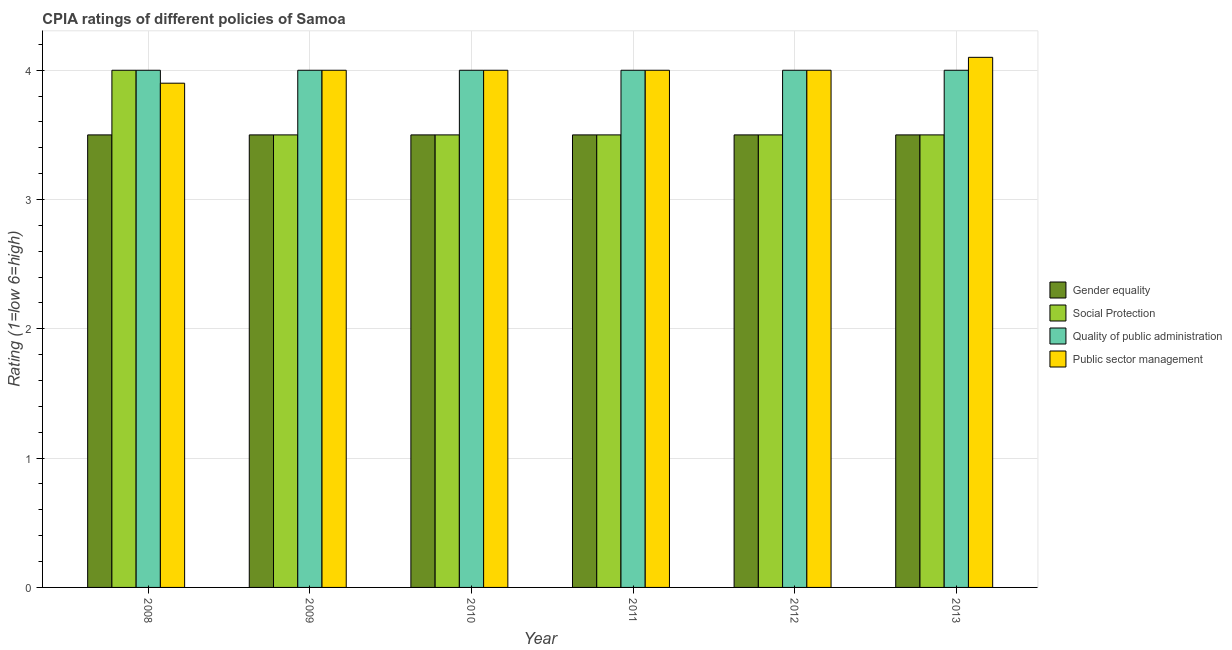How many bars are there on the 4th tick from the left?
Provide a short and direct response. 4. How many bars are there on the 6th tick from the right?
Your answer should be compact. 4. What is the label of the 1st group of bars from the left?
Give a very brief answer. 2008. What is the cpia rating of social protection in 2012?
Provide a short and direct response. 3.5. In which year was the cpia rating of quality of public administration maximum?
Make the answer very short. 2008. In which year was the cpia rating of gender equality minimum?
Give a very brief answer. 2008. What is the total cpia rating of social protection in the graph?
Provide a succinct answer. 21.5. What is the difference between the cpia rating of public sector management in 2010 and that in 2013?
Give a very brief answer. -0.1. What is the difference between the cpia rating of social protection in 2008 and the cpia rating of gender equality in 2011?
Your answer should be compact. 0.5. What is the average cpia rating of quality of public administration per year?
Provide a succinct answer. 4. Is the cpia rating of quality of public administration in 2011 less than that in 2012?
Your answer should be compact. No. Is the difference between the cpia rating of social protection in 2009 and 2012 greater than the difference between the cpia rating of quality of public administration in 2009 and 2012?
Make the answer very short. No. What is the difference between the highest and the second highest cpia rating of social protection?
Your answer should be compact. 0.5. What is the difference between the highest and the lowest cpia rating of social protection?
Keep it short and to the point. 0.5. Is the sum of the cpia rating of gender equality in 2008 and 2012 greater than the maximum cpia rating of public sector management across all years?
Make the answer very short. Yes. What does the 4th bar from the left in 2011 represents?
Offer a very short reply. Public sector management. What does the 2nd bar from the right in 2008 represents?
Give a very brief answer. Quality of public administration. How many bars are there?
Your answer should be compact. 24. Are all the bars in the graph horizontal?
Give a very brief answer. No. How many years are there in the graph?
Offer a terse response. 6. What is the difference between two consecutive major ticks on the Y-axis?
Your answer should be very brief. 1. Are the values on the major ticks of Y-axis written in scientific E-notation?
Your answer should be very brief. No. Does the graph contain any zero values?
Give a very brief answer. No. Does the graph contain grids?
Your answer should be compact. Yes. Where does the legend appear in the graph?
Your answer should be compact. Center right. How are the legend labels stacked?
Your answer should be compact. Vertical. What is the title of the graph?
Offer a terse response. CPIA ratings of different policies of Samoa. What is the Rating (1=low 6=high) of Quality of public administration in 2008?
Offer a very short reply. 4. What is the Rating (1=low 6=high) in Gender equality in 2009?
Ensure brevity in your answer.  3.5. What is the Rating (1=low 6=high) of Social Protection in 2009?
Your response must be concise. 3.5. What is the Rating (1=low 6=high) in Quality of public administration in 2009?
Ensure brevity in your answer.  4. What is the Rating (1=low 6=high) in Gender equality in 2010?
Offer a terse response. 3.5. What is the Rating (1=low 6=high) in Social Protection in 2010?
Provide a short and direct response. 3.5. What is the Rating (1=low 6=high) in Quality of public administration in 2010?
Your answer should be compact. 4. What is the Rating (1=low 6=high) in Public sector management in 2010?
Provide a succinct answer. 4. What is the Rating (1=low 6=high) of Public sector management in 2011?
Give a very brief answer. 4. What is the Rating (1=low 6=high) in Social Protection in 2012?
Give a very brief answer. 3.5. What is the Rating (1=low 6=high) of Quality of public administration in 2012?
Provide a short and direct response. 4. What is the Rating (1=low 6=high) in Public sector management in 2012?
Offer a very short reply. 4. What is the Rating (1=low 6=high) of Social Protection in 2013?
Offer a very short reply. 3.5. What is the Rating (1=low 6=high) in Quality of public administration in 2013?
Offer a terse response. 4. Across all years, what is the maximum Rating (1=low 6=high) of Social Protection?
Your answer should be very brief. 4. Across all years, what is the maximum Rating (1=low 6=high) of Public sector management?
Your answer should be very brief. 4.1. Across all years, what is the minimum Rating (1=low 6=high) of Social Protection?
Offer a terse response. 3.5. What is the total Rating (1=low 6=high) in Gender equality in the graph?
Offer a terse response. 21. What is the total Rating (1=low 6=high) in Social Protection in the graph?
Ensure brevity in your answer.  21.5. What is the total Rating (1=low 6=high) of Quality of public administration in the graph?
Provide a short and direct response. 24. What is the difference between the Rating (1=low 6=high) in Public sector management in 2008 and that in 2009?
Keep it short and to the point. -0.1. What is the difference between the Rating (1=low 6=high) of Gender equality in 2008 and that in 2010?
Your response must be concise. 0. What is the difference between the Rating (1=low 6=high) of Quality of public administration in 2008 and that in 2010?
Make the answer very short. 0. What is the difference between the Rating (1=low 6=high) of Gender equality in 2008 and that in 2011?
Make the answer very short. 0. What is the difference between the Rating (1=low 6=high) of Quality of public administration in 2008 and that in 2011?
Your response must be concise. 0. What is the difference between the Rating (1=low 6=high) in Public sector management in 2008 and that in 2011?
Provide a succinct answer. -0.1. What is the difference between the Rating (1=low 6=high) in Gender equality in 2008 and that in 2012?
Offer a terse response. 0. What is the difference between the Rating (1=low 6=high) in Social Protection in 2008 and that in 2012?
Your answer should be very brief. 0.5. What is the difference between the Rating (1=low 6=high) in Quality of public administration in 2008 and that in 2012?
Provide a succinct answer. 0. What is the difference between the Rating (1=low 6=high) in Public sector management in 2008 and that in 2012?
Ensure brevity in your answer.  -0.1. What is the difference between the Rating (1=low 6=high) of Social Protection in 2008 and that in 2013?
Your answer should be very brief. 0.5. What is the difference between the Rating (1=low 6=high) in Quality of public administration in 2008 and that in 2013?
Your answer should be compact. 0. What is the difference between the Rating (1=low 6=high) in Quality of public administration in 2009 and that in 2010?
Provide a succinct answer. 0. What is the difference between the Rating (1=low 6=high) of Public sector management in 2009 and that in 2010?
Provide a succinct answer. 0. What is the difference between the Rating (1=low 6=high) in Public sector management in 2009 and that in 2011?
Give a very brief answer. 0. What is the difference between the Rating (1=low 6=high) of Gender equality in 2009 and that in 2012?
Your answer should be compact. 0. What is the difference between the Rating (1=low 6=high) of Social Protection in 2009 and that in 2012?
Ensure brevity in your answer.  0. What is the difference between the Rating (1=low 6=high) in Public sector management in 2009 and that in 2012?
Ensure brevity in your answer.  0. What is the difference between the Rating (1=low 6=high) in Gender equality in 2009 and that in 2013?
Give a very brief answer. 0. What is the difference between the Rating (1=low 6=high) in Quality of public administration in 2009 and that in 2013?
Your response must be concise. 0. What is the difference between the Rating (1=low 6=high) of Public sector management in 2009 and that in 2013?
Your answer should be compact. -0.1. What is the difference between the Rating (1=low 6=high) in Social Protection in 2010 and that in 2011?
Ensure brevity in your answer.  0. What is the difference between the Rating (1=low 6=high) in Quality of public administration in 2010 and that in 2011?
Make the answer very short. 0. What is the difference between the Rating (1=low 6=high) of Quality of public administration in 2010 and that in 2012?
Ensure brevity in your answer.  0. What is the difference between the Rating (1=low 6=high) of Gender equality in 2011 and that in 2012?
Give a very brief answer. 0. What is the difference between the Rating (1=low 6=high) in Gender equality in 2011 and that in 2013?
Offer a very short reply. 0. What is the difference between the Rating (1=low 6=high) in Social Protection in 2011 and that in 2013?
Your answer should be compact. 0. What is the difference between the Rating (1=low 6=high) in Quality of public administration in 2012 and that in 2013?
Give a very brief answer. 0. What is the difference between the Rating (1=low 6=high) in Public sector management in 2012 and that in 2013?
Offer a very short reply. -0.1. What is the difference between the Rating (1=low 6=high) of Gender equality in 2008 and the Rating (1=low 6=high) of Public sector management in 2009?
Offer a terse response. -0.5. What is the difference between the Rating (1=low 6=high) of Quality of public administration in 2008 and the Rating (1=low 6=high) of Public sector management in 2009?
Your answer should be very brief. 0. What is the difference between the Rating (1=low 6=high) of Gender equality in 2008 and the Rating (1=low 6=high) of Quality of public administration in 2012?
Offer a very short reply. -0.5. What is the difference between the Rating (1=low 6=high) in Gender equality in 2008 and the Rating (1=low 6=high) in Public sector management in 2012?
Give a very brief answer. -0.5. What is the difference between the Rating (1=low 6=high) in Social Protection in 2008 and the Rating (1=low 6=high) in Quality of public administration in 2012?
Ensure brevity in your answer.  0. What is the difference between the Rating (1=low 6=high) of Social Protection in 2008 and the Rating (1=low 6=high) of Public sector management in 2012?
Offer a terse response. 0. What is the difference between the Rating (1=low 6=high) of Quality of public administration in 2008 and the Rating (1=low 6=high) of Public sector management in 2012?
Your answer should be compact. 0. What is the difference between the Rating (1=low 6=high) in Gender equality in 2008 and the Rating (1=low 6=high) in Social Protection in 2013?
Ensure brevity in your answer.  0. What is the difference between the Rating (1=low 6=high) of Gender equality in 2008 and the Rating (1=low 6=high) of Public sector management in 2013?
Ensure brevity in your answer.  -0.6. What is the difference between the Rating (1=low 6=high) of Social Protection in 2008 and the Rating (1=low 6=high) of Quality of public administration in 2013?
Give a very brief answer. 0. What is the difference between the Rating (1=low 6=high) of Quality of public administration in 2008 and the Rating (1=low 6=high) of Public sector management in 2013?
Your answer should be compact. -0.1. What is the difference between the Rating (1=low 6=high) in Gender equality in 2009 and the Rating (1=low 6=high) in Quality of public administration in 2010?
Offer a very short reply. -0.5. What is the difference between the Rating (1=low 6=high) of Social Protection in 2009 and the Rating (1=low 6=high) of Quality of public administration in 2010?
Your response must be concise. -0.5. What is the difference between the Rating (1=low 6=high) of Gender equality in 2009 and the Rating (1=low 6=high) of Public sector management in 2011?
Keep it short and to the point. -0.5. What is the difference between the Rating (1=low 6=high) in Quality of public administration in 2009 and the Rating (1=low 6=high) in Public sector management in 2011?
Offer a terse response. 0. What is the difference between the Rating (1=low 6=high) of Gender equality in 2009 and the Rating (1=low 6=high) of Social Protection in 2012?
Provide a short and direct response. 0. What is the difference between the Rating (1=low 6=high) in Gender equality in 2009 and the Rating (1=low 6=high) in Public sector management in 2012?
Offer a terse response. -0.5. What is the difference between the Rating (1=low 6=high) in Social Protection in 2009 and the Rating (1=low 6=high) in Quality of public administration in 2012?
Your answer should be very brief. -0.5. What is the difference between the Rating (1=low 6=high) of Social Protection in 2009 and the Rating (1=low 6=high) of Public sector management in 2012?
Your response must be concise. -0.5. What is the difference between the Rating (1=low 6=high) in Quality of public administration in 2009 and the Rating (1=low 6=high) in Public sector management in 2012?
Keep it short and to the point. 0. What is the difference between the Rating (1=low 6=high) of Gender equality in 2009 and the Rating (1=low 6=high) of Social Protection in 2013?
Keep it short and to the point. 0. What is the difference between the Rating (1=low 6=high) in Quality of public administration in 2009 and the Rating (1=low 6=high) in Public sector management in 2013?
Keep it short and to the point. -0.1. What is the difference between the Rating (1=low 6=high) of Gender equality in 2010 and the Rating (1=low 6=high) of Social Protection in 2011?
Keep it short and to the point. 0. What is the difference between the Rating (1=low 6=high) in Gender equality in 2010 and the Rating (1=low 6=high) in Quality of public administration in 2011?
Provide a short and direct response. -0.5. What is the difference between the Rating (1=low 6=high) in Social Protection in 2010 and the Rating (1=low 6=high) in Quality of public administration in 2011?
Your answer should be compact. -0.5. What is the difference between the Rating (1=low 6=high) of Quality of public administration in 2010 and the Rating (1=low 6=high) of Public sector management in 2011?
Your answer should be compact. 0. What is the difference between the Rating (1=low 6=high) in Gender equality in 2010 and the Rating (1=low 6=high) in Quality of public administration in 2012?
Ensure brevity in your answer.  -0.5. What is the difference between the Rating (1=low 6=high) of Social Protection in 2010 and the Rating (1=low 6=high) of Quality of public administration in 2012?
Ensure brevity in your answer.  -0.5. What is the difference between the Rating (1=low 6=high) in Social Protection in 2010 and the Rating (1=low 6=high) in Public sector management in 2012?
Your answer should be very brief. -0.5. What is the difference between the Rating (1=low 6=high) of Gender equality in 2010 and the Rating (1=low 6=high) of Social Protection in 2013?
Provide a short and direct response. 0. What is the difference between the Rating (1=low 6=high) in Gender equality in 2010 and the Rating (1=low 6=high) in Public sector management in 2013?
Keep it short and to the point. -0.6. What is the difference between the Rating (1=low 6=high) in Social Protection in 2010 and the Rating (1=low 6=high) in Public sector management in 2013?
Offer a terse response. -0.6. What is the difference between the Rating (1=low 6=high) in Quality of public administration in 2010 and the Rating (1=low 6=high) in Public sector management in 2013?
Keep it short and to the point. -0.1. What is the difference between the Rating (1=low 6=high) of Gender equality in 2011 and the Rating (1=low 6=high) of Quality of public administration in 2012?
Keep it short and to the point. -0.5. What is the difference between the Rating (1=low 6=high) in Quality of public administration in 2011 and the Rating (1=low 6=high) in Public sector management in 2012?
Provide a short and direct response. 0. What is the difference between the Rating (1=low 6=high) in Gender equality in 2011 and the Rating (1=low 6=high) in Social Protection in 2013?
Provide a short and direct response. 0. What is the difference between the Rating (1=low 6=high) in Gender equality in 2011 and the Rating (1=low 6=high) in Quality of public administration in 2013?
Your response must be concise. -0.5. What is the difference between the Rating (1=low 6=high) in Quality of public administration in 2011 and the Rating (1=low 6=high) in Public sector management in 2013?
Ensure brevity in your answer.  -0.1. What is the difference between the Rating (1=low 6=high) of Gender equality in 2012 and the Rating (1=low 6=high) of Quality of public administration in 2013?
Provide a succinct answer. -0.5. What is the difference between the Rating (1=low 6=high) of Social Protection in 2012 and the Rating (1=low 6=high) of Public sector management in 2013?
Your response must be concise. -0.6. What is the difference between the Rating (1=low 6=high) in Quality of public administration in 2012 and the Rating (1=low 6=high) in Public sector management in 2013?
Offer a very short reply. -0.1. What is the average Rating (1=low 6=high) of Social Protection per year?
Your response must be concise. 3.58. What is the average Rating (1=low 6=high) in Quality of public administration per year?
Offer a terse response. 4. In the year 2008, what is the difference between the Rating (1=low 6=high) of Gender equality and Rating (1=low 6=high) of Public sector management?
Ensure brevity in your answer.  -0.4. In the year 2008, what is the difference between the Rating (1=low 6=high) in Social Protection and Rating (1=low 6=high) in Public sector management?
Ensure brevity in your answer.  0.1. In the year 2009, what is the difference between the Rating (1=low 6=high) in Gender equality and Rating (1=low 6=high) in Quality of public administration?
Give a very brief answer. -0.5. In the year 2010, what is the difference between the Rating (1=low 6=high) in Gender equality and Rating (1=low 6=high) in Social Protection?
Offer a terse response. 0. In the year 2010, what is the difference between the Rating (1=low 6=high) in Gender equality and Rating (1=low 6=high) in Quality of public administration?
Offer a terse response. -0.5. In the year 2010, what is the difference between the Rating (1=low 6=high) in Gender equality and Rating (1=low 6=high) in Public sector management?
Offer a terse response. -0.5. In the year 2011, what is the difference between the Rating (1=low 6=high) in Gender equality and Rating (1=low 6=high) in Social Protection?
Make the answer very short. 0. In the year 2011, what is the difference between the Rating (1=low 6=high) in Gender equality and Rating (1=low 6=high) in Public sector management?
Make the answer very short. -0.5. In the year 2011, what is the difference between the Rating (1=low 6=high) in Social Protection and Rating (1=low 6=high) in Public sector management?
Make the answer very short. -0.5. In the year 2012, what is the difference between the Rating (1=low 6=high) in Gender equality and Rating (1=low 6=high) in Social Protection?
Give a very brief answer. 0. In the year 2012, what is the difference between the Rating (1=low 6=high) of Social Protection and Rating (1=low 6=high) of Quality of public administration?
Provide a succinct answer. -0.5. In the year 2012, what is the difference between the Rating (1=low 6=high) in Social Protection and Rating (1=low 6=high) in Public sector management?
Provide a succinct answer. -0.5. In the year 2012, what is the difference between the Rating (1=low 6=high) in Quality of public administration and Rating (1=low 6=high) in Public sector management?
Provide a short and direct response. 0. In the year 2013, what is the difference between the Rating (1=low 6=high) of Gender equality and Rating (1=low 6=high) of Quality of public administration?
Provide a short and direct response. -0.5. In the year 2013, what is the difference between the Rating (1=low 6=high) in Social Protection and Rating (1=low 6=high) in Quality of public administration?
Provide a succinct answer. -0.5. In the year 2013, what is the difference between the Rating (1=low 6=high) in Quality of public administration and Rating (1=low 6=high) in Public sector management?
Offer a terse response. -0.1. What is the ratio of the Rating (1=low 6=high) of Public sector management in 2008 to that in 2009?
Ensure brevity in your answer.  0.97. What is the ratio of the Rating (1=low 6=high) in Gender equality in 2008 to that in 2010?
Your answer should be very brief. 1. What is the ratio of the Rating (1=low 6=high) of Social Protection in 2008 to that in 2010?
Your response must be concise. 1.14. What is the ratio of the Rating (1=low 6=high) in Quality of public administration in 2008 to that in 2010?
Offer a terse response. 1. What is the ratio of the Rating (1=low 6=high) of Quality of public administration in 2008 to that in 2011?
Your answer should be compact. 1. What is the ratio of the Rating (1=low 6=high) of Public sector management in 2008 to that in 2011?
Your answer should be compact. 0.97. What is the ratio of the Rating (1=low 6=high) in Quality of public administration in 2008 to that in 2012?
Ensure brevity in your answer.  1. What is the ratio of the Rating (1=low 6=high) in Gender equality in 2008 to that in 2013?
Provide a short and direct response. 1. What is the ratio of the Rating (1=low 6=high) in Public sector management in 2008 to that in 2013?
Ensure brevity in your answer.  0.95. What is the ratio of the Rating (1=low 6=high) in Gender equality in 2009 to that in 2010?
Ensure brevity in your answer.  1. What is the ratio of the Rating (1=low 6=high) of Public sector management in 2009 to that in 2011?
Provide a short and direct response. 1. What is the ratio of the Rating (1=low 6=high) of Gender equality in 2009 to that in 2012?
Provide a short and direct response. 1. What is the ratio of the Rating (1=low 6=high) in Gender equality in 2009 to that in 2013?
Keep it short and to the point. 1. What is the ratio of the Rating (1=low 6=high) in Quality of public administration in 2009 to that in 2013?
Offer a very short reply. 1. What is the ratio of the Rating (1=low 6=high) of Public sector management in 2009 to that in 2013?
Your answer should be very brief. 0.98. What is the ratio of the Rating (1=low 6=high) in Social Protection in 2010 to that in 2011?
Your response must be concise. 1. What is the ratio of the Rating (1=low 6=high) in Quality of public administration in 2010 to that in 2011?
Provide a short and direct response. 1. What is the ratio of the Rating (1=low 6=high) in Public sector management in 2010 to that in 2011?
Make the answer very short. 1. What is the ratio of the Rating (1=low 6=high) in Quality of public administration in 2010 to that in 2013?
Offer a very short reply. 1. What is the ratio of the Rating (1=low 6=high) in Public sector management in 2010 to that in 2013?
Give a very brief answer. 0.98. What is the ratio of the Rating (1=low 6=high) of Quality of public administration in 2011 to that in 2012?
Give a very brief answer. 1. What is the ratio of the Rating (1=low 6=high) of Gender equality in 2011 to that in 2013?
Make the answer very short. 1. What is the ratio of the Rating (1=low 6=high) of Public sector management in 2011 to that in 2013?
Give a very brief answer. 0.98. What is the ratio of the Rating (1=low 6=high) of Gender equality in 2012 to that in 2013?
Your answer should be very brief. 1. What is the ratio of the Rating (1=low 6=high) in Social Protection in 2012 to that in 2013?
Your answer should be very brief. 1. What is the ratio of the Rating (1=low 6=high) in Public sector management in 2012 to that in 2013?
Your response must be concise. 0.98. What is the difference between the highest and the second highest Rating (1=low 6=high) of Gender equality?
Make the answer very short. 0. What is the difference between the highest and the second highest Rating (1=low 6=high) of Public sector management?
Give a very brief answer. 0.1. 